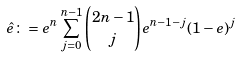Convert formula to latex. <formula><loc_0><loc_0><loc_500><loc_500>\hat { e } \colon = e ^ { n } \sum _ { j = 0 } ^ { n - 1 } \binom { 2 n - 1 } { j } e ^ { n - 1 - j } ( 1 - e ) ^ { j }</formula> 